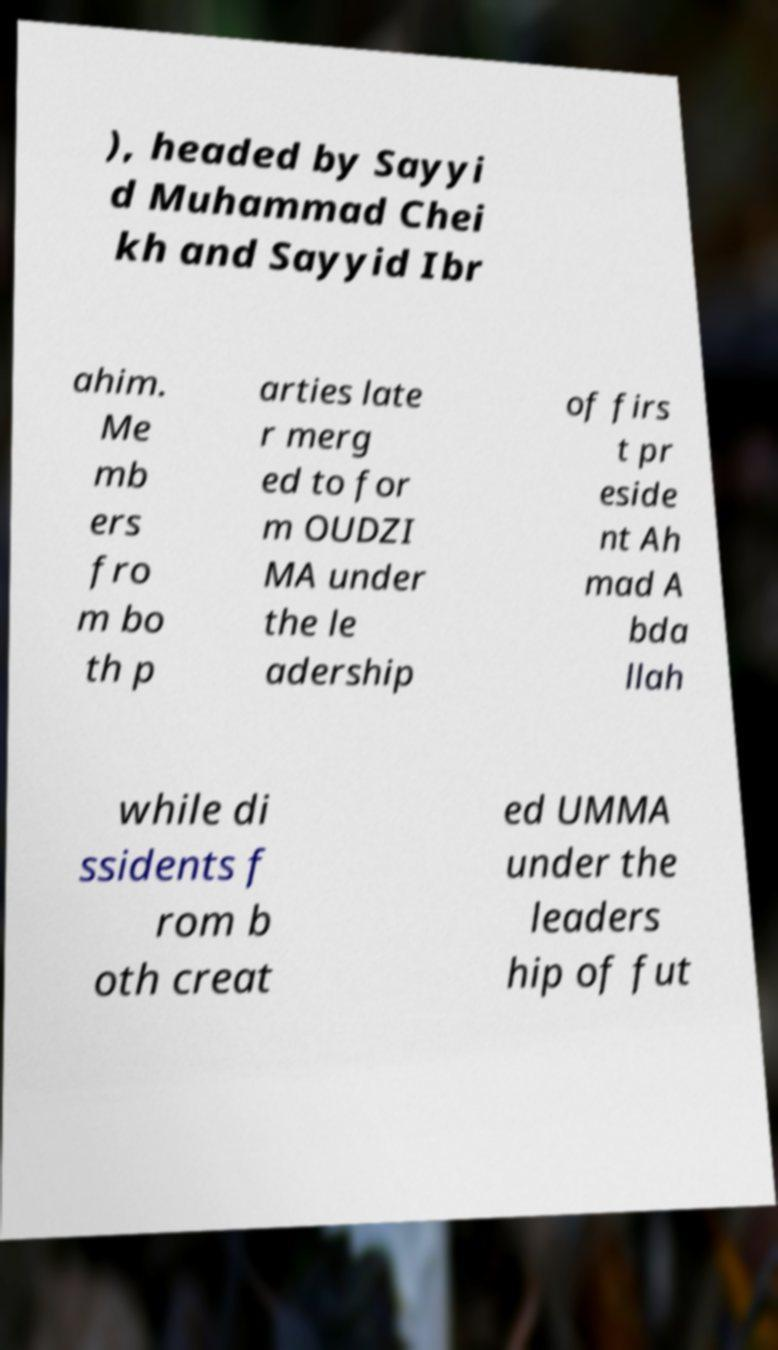Can you read and provide the text displayed in the image?This photo seems to have some interesting text. Can you extract and type it out for me? ), headed by Sayyi d Muhammad Chei kh and Sayyid Ibr ahim. Me mb ers fro m bo th p arties late r merg ed to for m OUDZI MA under the le adership of firs t pr eside nt Ah mad A bda llah while di ssidents f rom b oth creat ed UMMA under the leaders hip of fut 